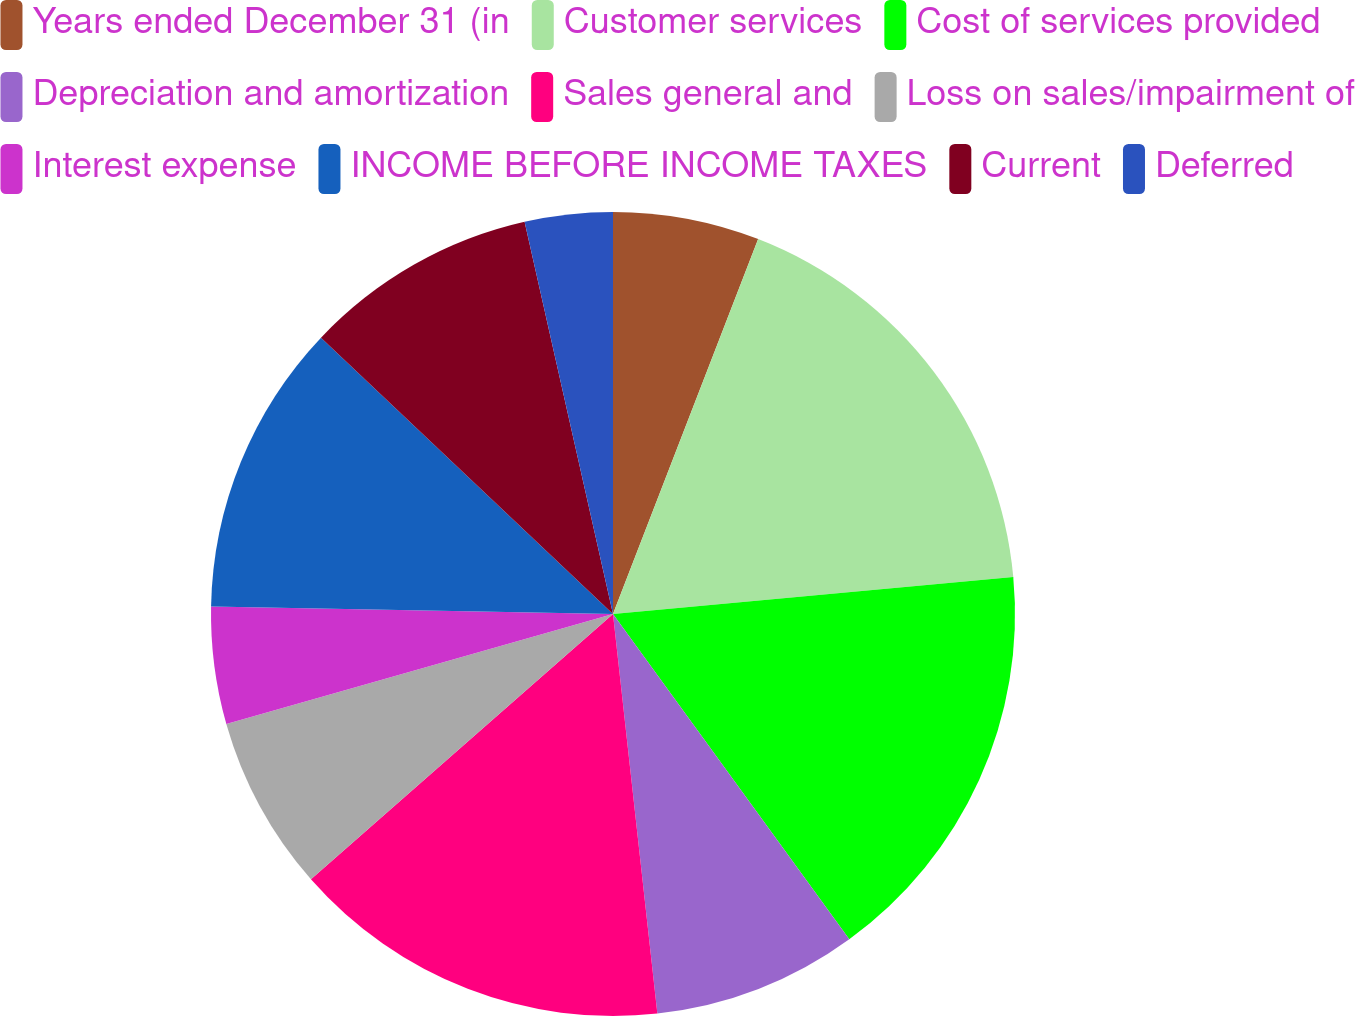Convert chart to OTSL. <chart><loc_0><loc_0><loc_500><loc_500><pie_chart><fcel>Years ended December 31 (in<fcel>Customer services<fcel>Cost of services provided<fcel>Depreciation and amortization<fcel>Sales general and<fcel>Loss on sales/impairment of<fcel>Interest expense<fcel>INCOME BEFORE INCOME TAXES<fcel>Current<fcel>Deferred<nl><fcel>5.88%<fcel>17.65%<fcel>16.47%<fcel>8.24%<fcel>15.29%<fcel>7.06%<fcel>4.71%<fcel>11.76%<fcel>9.41%<fcel>3.53%<nl></chart> 